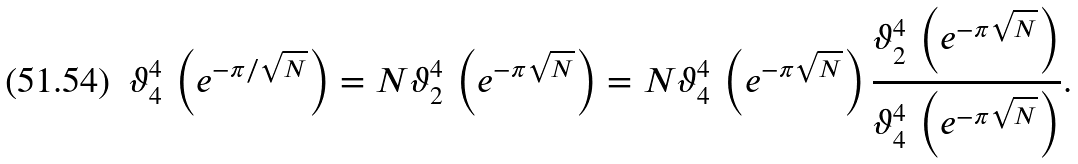Convert formula to latex. <formula><loc_0><loc_0><loc_500><loc_500>\vartheta _ { 4 } ^ { 4 } \, \left ( e ^ { - \pi / \sqrt { N } } \right ) = N \vartheta _ { 2 } ^ { 4 } \, \left ( e ^ { - \pi \sqrt { N } } \right ) = N \vartheta _ { 4 } ^ { 4 } \, \left ( e ^ { - \pi \sqrt { N } } \right ) \frac { \vartheta _ { 2 } ^ { 4 } \, \left ( e ^ { - \pi \sqrt { N } } \right ) } { \vartheta _ { 4 } ^ { 4 } \, \left ( e ^ { - \pi \sqrt { N } } \right ) } .</formula> 